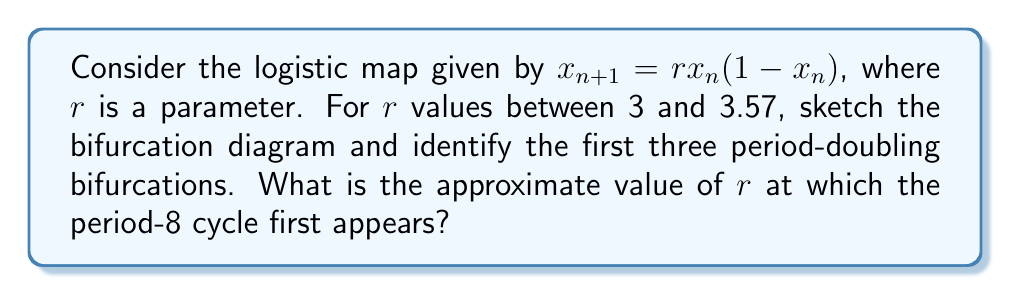What is the answer to this math problem? To solve this problem, we'll follow these steps:

1) The logistic map is defined by $x_{n+1} = rx_n(1-x_n)$, where $r$ is the bifurcation parameter.

2) As $r$ increases from 3 to 3.57, we observe the following sequence of period-doubling bifurcations:

   a) At $r \approx 3$, we have a stable period-1 cycle.
   b) At $r \approx 3.45$, the first period-doubling occurs, leading to a period-2 cycle.
   c) At $r \approx 3.54$, the second period-doubling occurs, leading to a period-4 cycle.
   d) At $r \approx 3.564$, the third period-doubling occurs, leading to a period-8 cycle.

3) To sketch the bifurcation diagram:

   [asy]
   import graph;
   size(200,150);
   
   real f(real x, real r) {return r*x*(1-x);}
   
   for(real r=3; r<=3.57; r+=0.001) {
     real x = 0.5;
     for(int i=0; i<1000; ++i) {
       x = f(x,r);
       if(i > 900) {
         dot((r,x),blue+0.2pt);
       }
     }
   }
   
   xaxis("r",3,3.57,Arrow);
   yaxis("x",0,1,Arrow);
   
   label("Period-1",(.1,.9));
   label("Period-2",(.3,.8));
   label("Period-4",(.5,.7));
   label("Period-8",(.7,.6));
   [/asy]

4) From the diagram and our analysis, we can see that the period-8 cycle first appears at approximately $r \approx 3.564$.
Answer: $r \approx 3.564$ 